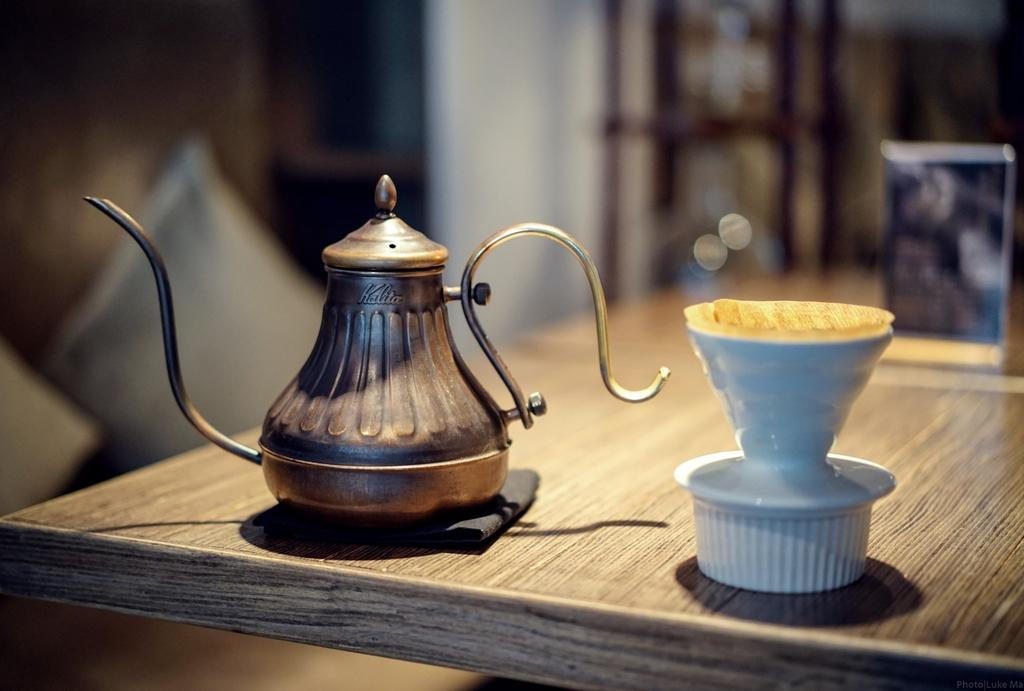What type of object is the main subject in the image? There is an antique teapot in the image. What material is the teapot made of? The teapot is made of ceramic. What is on the table in the image? There is a board on the table in the image. What can be seen in the background of the image? There is a wall visible in the image. What type of furniture or accessory is present in the image? There are cushions in the image. What type of team is playing a game in the image? There is no team or game present in the image; it features an antique teapot, ceramic, a board, a wall, and cushions. What type of hair can be seen on the cushions in the image? There is no hair visible on the cushions in the image; they are made of fabric or other materials. 